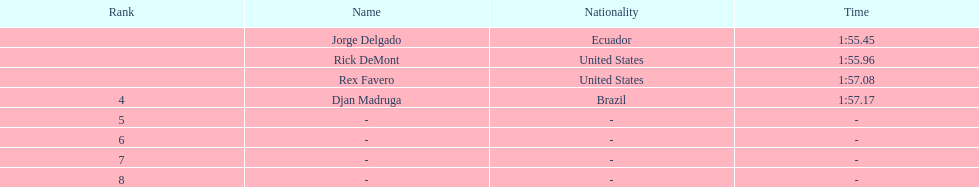Who had the fastest finishing time? Jorge Delgado. 